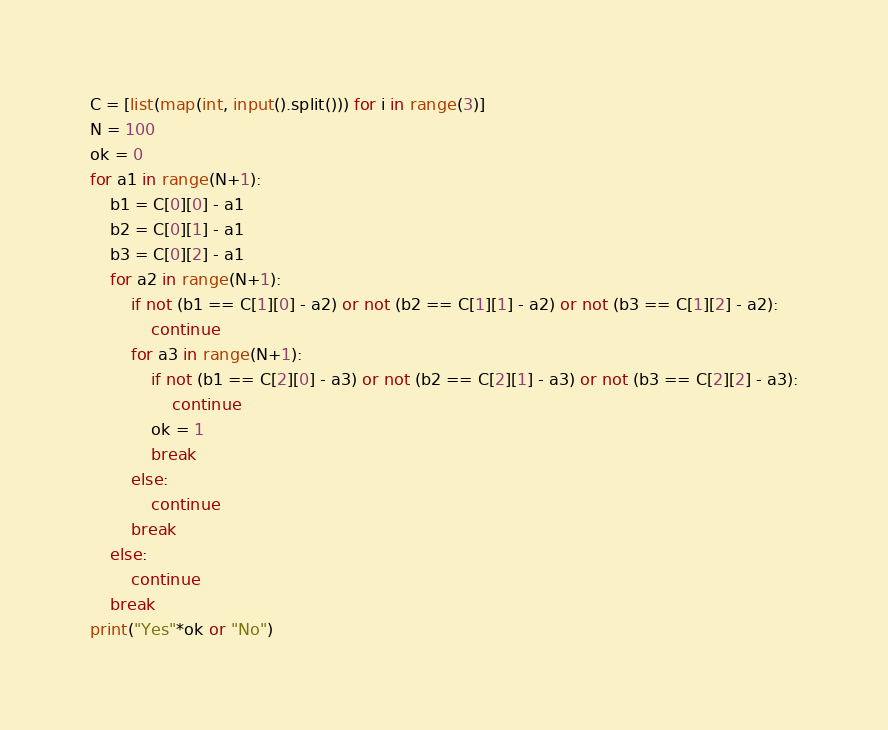Convert code to text. <code><loc_0><loc_0><loc_500><loc_500><_Python_>C = [list(map(int, input().split())) for i in range(3)]
N = 100
ok = 0
for a1 in range(N+1):
    b1 = C[0][0] - a1
    b2 = C[0][1] - a1
    b3 = C[0][2] - a1
    for a2 in range(N+1):
        if not (b1 == C[1][0] - a2) or not (b2 == C[1][1] - a2) or not (b3 == C[1][2] - a2):
            continue
        for a3 in range(N+1):
            if not (b1 == C[2][0] - a3) or not (b2 == C[2][1] - a3) or not (b3 == C[2][2] - a3):
                continue
            ok = 1
            break
        else:
            continue
        break
    else:
        continue
    break
print("Yes"*ok or "No")
</code> 